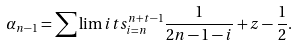<formula> <loc_0><loc_0><loc_500><loc_500>\alpha _ { n - 1 } = \sum \lim i t s _ { i = n } ^ { n + t - 1 } \frac { 1 } { 2 n - 1 - i } + z - \frac { 1 } { 2 } .</formula> 